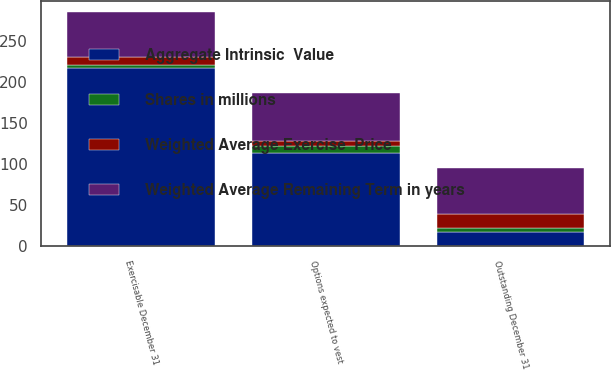Convert chart to OTSL. <chart><loc_0><loc_0><loc_500><loc_500><stacked_bar_chart><ecel><fcel>Outstanding December 31<fcel>Exercisable December 31<fcel>Options expected to vest<nl><fcel>Weighted Average Exercise  Price<fcel>17<fcel>10.1<fcel>6.5<nl><fcel>Weighted Average Remaining Term in years<fcel>55.35<fcel>53.77<fcel>57.47<nl><fcel>Shares in millions<fcel>5.5<fcel>3.9<fcel>7.9<nl><fcel>Aggregate Intrinsic  Value<fcel>17<fcel>216.7<fcel>114<nl></chart> 